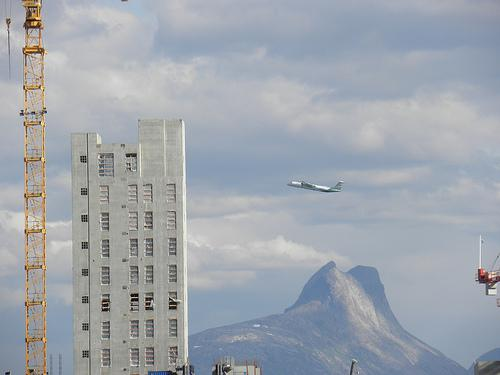Question: what is in the background?
Choices:
A. A business.
B. A street light.
C. A mountain and building.
D. A cloud.
Answer with the letter. Answer: C Question: why the plane is flying?
Choices:
A. To travel.
B. Carrying passengers.
C. Escorting people.
D. Because it does.
Answer with the letter. Answer: A Question: what is the color of the building?
Choices:
A. Gray.
B. White.
C. Red.
D. Blue.
Answer with the letter. Answer: A Question: what is the color of the crane?
Choices:
A. Yellow.
B. Red.
C. Black.
D. Green.
Answer with the letter. Answer: A Question: who is on the crane?
Choices:
A. No one.
B. A man.
C. A woman.
D. A child.
Answer with the letter. Answer: A Question: where is the mountain?
Choices:
A. Behind the city.
B. On the west coast.
C. On the east coast.
D. In the desert.
Answer with the letter. Answer: A 